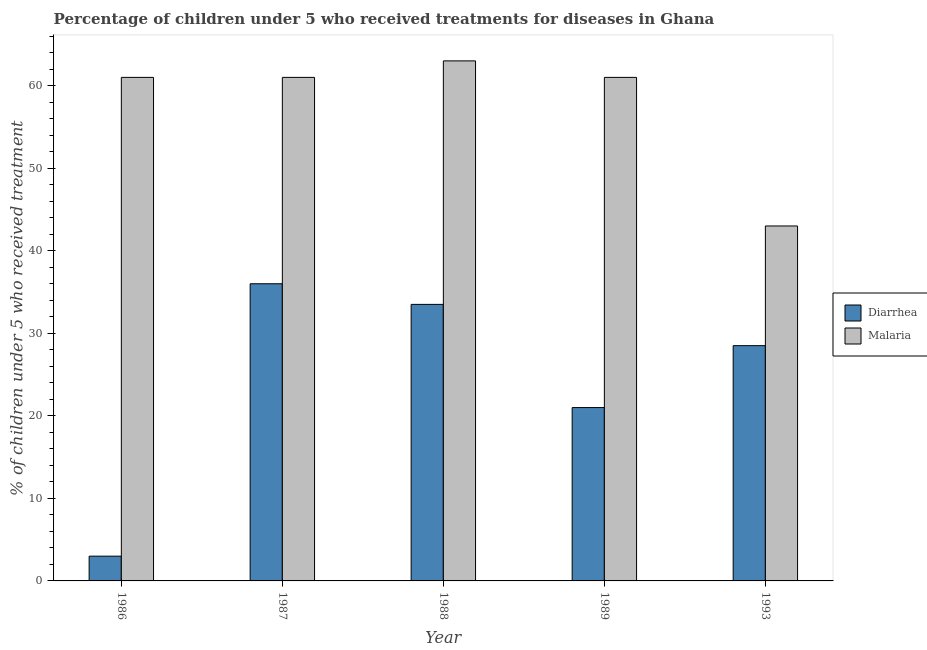Across all years, what is the minimum percentage of children who received treatment for diarrhoea?
Provide a short and direct response. 3. In which year was the percentage of children who received treatment for diarrhoea maximum?
Provide a short and direct response. 1987. In which year was the percentage of children who received treatment for diarrhoea minimum?
Provide a short and direct response. 1986. What is the total percentage of children who received treatment for diarrhoea in the graph?
Ensure brevity in your answer.  122. What is the difference between the percentage of children who received treatment for diarrhoea in 1986 and that in 1993?
Your answer should be very brief. -25.5. What is the average percentage of children who received treatment for malaria per year?
Your response must be concise. 57.8. In the year 1986, what is the difference between the percentage of children who received treatment for diarrhoea and percentage of children who received treatment for malaria?
Provide a short and direct response. 0. In how many years, is the percentage of children who received treatment for diarrhoea greater than 40 %?
Your answer should be compact. 0. What is the ratio of the percentage of children who received treatment for diarrhoea in 1986 to that in 1987?
Provide a short and direct response. 0.08. Is the difference between the percentage of children who received treatment for malaria in 1989 and 1993 greater than the difference between the percentage of children who received treatment for diarrhoea in 1989 and 1993?
Your answer should be compact. No. Is the sum of the percentage of children who received treatment for diarrhoea in 1986 and 1993 greater than the maximum percentage of children who received treatment for malaria across all years?
Provide a succinct answer. No. What does the 1st bar from the left in 1993 represents?
Offer a terse response. Diarrhea. What does the 2nd bar from the right in 1987 represents?
Give a very brief answer. Diarrhea. How many bars are there?
Offer a very short reply. 10. Are all the bars in the graph horizontal?
Your answer should be compact. No. How many years are there in the graph?
Offer a terse response. 5. Where does the legend appear in the graph?
Keep it short and to the point. Center right. What is the title of the graph?
Offer a very short reply. Percentage of children under 5 who received treatments for diseases in Ghana. Does "Commercial service exports" appear as one of the legend labels in the graph?
Offer a very short reply. No. What is the label or title of the Y-axis?
Keep it short and to the point. % of children under 5 who received treatment. What is the % of children under 5 who received treatment of Diarrhea in 1987?
Keep it short and to the point. 36. What is the % of children under 5 who received treatment of Diarrhea in 1988?
Provide a succinct answer. 33.5. What is the % of children under 5 who received treatment of Diarrhea in 1989?
Ensure brevity in your answer.  21. What is the % of children under 5 who received treatment of Malaria in 1993?
Your response must be concise. 43. Across all years, what is the maximum % of children under 5 who received treatment of Malaria?
Offer a terse response. 63. What is the total % of children under 5 who received treatment in Diarrhea in the graph?
Make the answer very short. 122. What is the total % of children under 5 who received treatment in Malaria in the graph?
Provide a succinct answer. 289. What is the difference between the % of children under 5 who received treatment of Diarrhea in 1986 and that in 1987?
Your answer should be very brief. -33. What is the difference between the % of children under 5 who received treatment of Diarrhea in 1986 and that in 1988?
Offer a very short reply. -30.5. What is the difference between the % of children under 5 who received treatment of Diarrhea in 1986 and that in 1989?
Keep it short and to the point. -18. What is the difference between the % of children under 5 who received treatment in Malaria in 1986 and that in 1989?
Your answer should be compact. 0. What is the difference between the % of children under 5 who received treatment in Diarrhea in 1986 and that in 1993?
Your answer should be compact. -25.5. What is the difference between the % of children under 5 who received treatment in Malaria in 1986 and that in 1993?
Your response must be concise. 18. What is the difference between the % of children under 5 who received treatment of Malaria in 1987 and that in 1988?
Your answer should be very brief. -2. What is the difference between the % of children under 5 who received treatment of Diarrhea in 1987 and that in 1989?
Your answer should be very brief. 15. What is the difference between the % of children under 5 who received treatment of Malaria in 1987 and that in 1989?
Give a very brief answer. 0. What is the difference between the % of children under 5 who received treatment in Diarrhea in 1987 and that in 1993?
Your response must be concise. 7.5. What is the difference between the % of children under 5 who received treatment of Malaria in 1988 and that in 1993?
Make the answer very short. 20. What is the difference between the % of children under 5 who received treatment in Diarrhea in 1989 and that in 1993?
Make the answer very short. -7.5. What is the difference between the % of children under 5 who received treatment of Malaria in 1989 and that in 1993?
Provide a short and direct response. 18. What is the difference between the % of children under 5 who received treatment in Diarrhea in 1986 and the % of children under 5 who received treatment in Malaria in 1987?
Your answer should be very brief. -58. What is the difference between the % of children under 5 who received treatment of Diarrhea in 1986 and the % of children under 5 who received treatment of Malaria in 1988?
Your answer should be very brief. -60. What is the difference between the % of children under 5 who received treatment in Diarrhea in 1986 and the % of children under 5 who received treatment in Malaria in 1989?
Provide a short and direct response. -58. What is the difference between the % of children under 5 who received treatment of Diarrhea in 1986 and the % of children under 5 who received treatment of Malaria in 1993?
Your answer should be compact. -40. What is the difference between the % of children under 5 who received treatment of Diarrhea in 1987 and the % of children under 5 who received treatment of Malaria in 1988?
Ensure brevity in your answer.  -27. What is the difference between the % of children under 5 who received treatment of Diarrhea in 1988 and the % of children under 5 who received treatment of Malaria in 1989?
Your response must be concise. -27.5. What is the difference between the % of children under 5 who received treatment of Diarrhea in 1988 and the % of children under 5 who received treatment of Malaria in 1993?
Offer a terse response. -9.5. What is the average % of children under 5 who received treatment of Diarrhea per year?
Ensure brevity in your answer.  24.4. What is the average % of children under 5 who received treatment of Malaria per year?
Provide a short and direct response. 57.8. In the year 1986, what is the difference between the % of children under 5 who received treatment of Diarrhea and % of children under 5 who received treatment of Malaria?
Keep it short and to the point. -58. In the year 1987, what is the difference between the % of children under 5 who received treatment in Diarrhea and % of children under 5 who received treatment in Malaria?
Your response must be concise. -25. In the year 1988, what is the difference between the % of children under 5 who received treatment of Diarrhea and % of children under 5 who received treatment of Malaria?
Ensure brevity in your answer.  -29.5. What is the ratio of the % of children under 5 who received treatment in Diarrhea in 1986 to that in 1987?
Ensure brevity in your answer.  0.08. What is the ratio of the % of children under 5 who received treatment in Malaria in 1986 to that in 1987?
Ensure brevity in your answer.  1. What is the ratio of the % of children under 5 who received treatment in Diarrhea in 1986 to that in 1988?
Provide a short and direct response. 0.09. What is the ratio of the % of children under 5 who received treatment in Malaria in 1986 to that in 1988?
Keep it short and to the point. 0.97. What is the ratio of the % of children under 5 who received treatment of Diarrhea in 1986 to that in 1989?
Your answer should be very brief. 0.14. What is the ratio of the % of children under 5 who received treatment of Malaria in 1986 to that in 1989?
Provide a succinct answer. 1. What is the ratio of the % of children under 5 who received treatment of Diarrhea in 1986 to that in 1993?
Keep it short and to the point. 0.11. What is the ratio of the % of children under 5 who received treatment in Malaria in 1986 to that in 1993?
Provide a short and direct response. 1.42. What is the ratio of the % of children under 5 who received treatment in Diarrhea in 1987 to that in 1988?
Offer a very short reply. 1.07. What is the ratio of the % of children under 5 who received treatment in Malaria in 1987 to that in 1988?
Provide a short and direct response. 0.97. What is the ratio of the % of children under 5 who received treatment of Diarrhea in 1987 to that in 1989?
Offer a very short reply. 1.71. What is the ratio of the % of children under 5 who received treatment in Malaria in 1987 to that in 1989?
Provide a succinct answer. 1. What is the ratio of the % of children under 5 who received treatment in Diarrhea in 1987 to that in 1993?
Keep it short and to the point. 1.26. What is the ratio of the % of children under 5 who received treatment in Malaria in 1987 to that in 1993?
Provide a succinct answer. 1.42. What is the ratio of the % of children under 5 who received treatment in Diarrhea in 1988 to that in 1989?
Offer a very short reply. 1.6. What is the ratio of the % of children under 5 who received treatment in Malaria in 1988 to that in 1989?
Your answer should be very brief. 1.03. What is the ratio of the % of children under 5 who received treatment of Diarrhea in 1988 to that in 1993?
Give a very brief answer. 1.18. What is the ratio of the % of children under 5 who received treatment in Malaria in 1988 to that in 1993?
Offer a very short reply. 1.47. What is the ratio of the % of children under 5 who received treatment of Diarrhea in 1989 to that in 1993?
Give a very brief answer. 0.74. What is the ratio of the % of children under 5 who received treatment in Malaria in 1989 to that in 1993?
Give a very brief answer. 1.42. What is the difference between the highest and the second highest % of children under 5 who received treatment in Diarrhea?
Offer a very short reply. 2.5. What is the difference between the highest and the lowest % of children under 5 who received treatment of Diarrhea?
Your response must be concise. 33. What is the difference between the highest and the lowest % of children under 5 who received treatment in Malaria?
Make the answer very short. 20. 